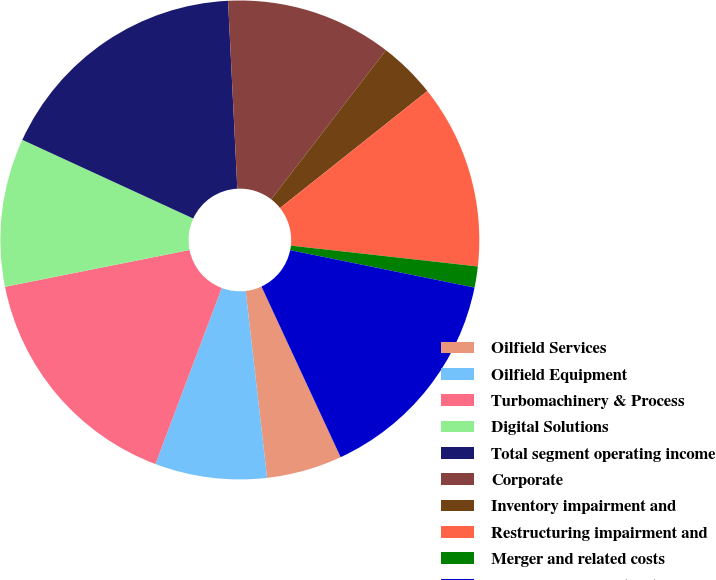Convert chart. <chart><loc_0><loc_0><loc_500><loc_500><pie_chart><fcel>Oilfield Services<fcel>Oilfield Equipment<fcel>Turbomachinery & Process<fcel>Digital Solutions<fcel>Total segment operating income<fcel>Corporate<fcel>Inventory impairment and<fcel>Restructuring impairment and<fcel>Merger and related costs<fcel>Operating income (loss)<nl><fcel>5.1%<fcel>7.55%<fcel>16.13%<fcel>10.0%<fcel>17.35%<fcel>11.23%<fcel>3.87%<fcel>12.45%<fcel>1.42%<fcel>14.9%<nl></chart> 